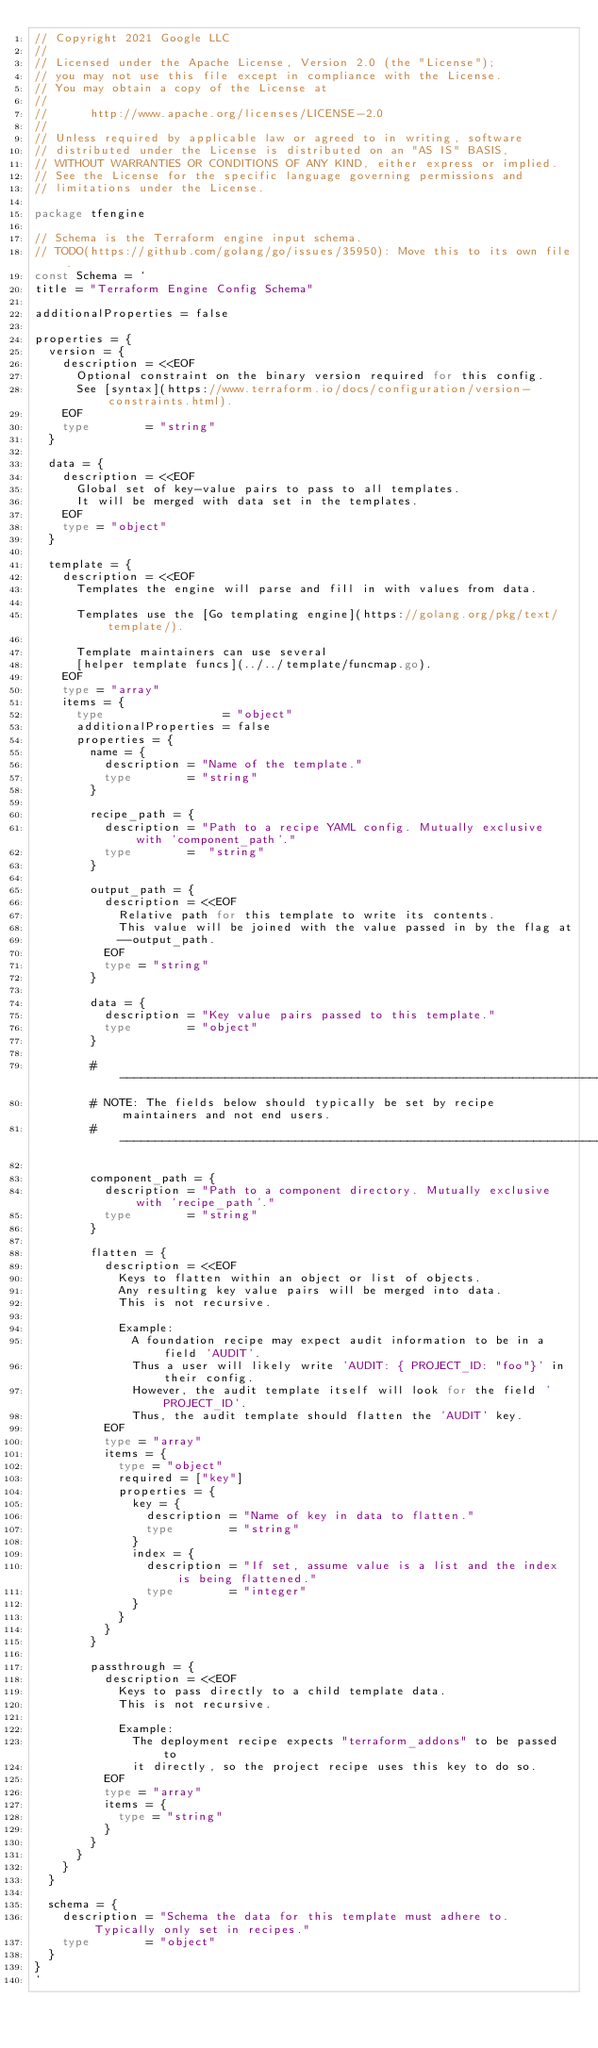Convert code to text. <code><loc_0><loc_0><loc_500><loc_500><_Go_>// Copyright 2021 Google LLC
//
// Licensed under the Apache License, Version 2.0 (the "License");
// you may not use this file except in compliance with the License.
// You may obtain a copy of the License at
//
//      http://www.apache.org/licenses/LICENSE-2.0
//
// Unless required by applicable law or agreed to in writing, software
// distributed under the License is distributed on an "AS IS" BASIS,
// WITHOUT WARRANTIES OR CONDITIONS OF ANY KIND, either express or implied.
// See the License for the specific language governing permissions and
// limitations under the License.

package tfengine

// Schema is the Terraform engine input schema.
// TODO(https://github.com/golang/go/issues/35950): Move this to its own file.
const Schema = `
title = "Terraform Engine Config Schema"

additionalProperties = false

properties = {
  version = {
    description = <<EOF
      Optional constraint on the binary version required for this config.
      See [syntax](https://www.terraform.io/docs/configuration/version-constraints.html).
    EOF
    type        = "string"
  }

  data = {
    description = <<EOF
      Global set of key-value pairs to pass to all templates.
      It will be merged with data set in the templates.
    EOF
    type = "object"
  }

  template = {
    description = <<EOF
      Templates the engine will parse and fill in with values from data.

      Templates use the [Go templating engine](https://golang.org/pkg/text/template/).

      Template maintainers can use several
      [helper template funcs](../../template/funcmap.go).
    EOF
    type = "array"
    items = {
      type                 = "object"
      additionalProperties = false
      properties = {
        name = {
          description = "Name of the template."
          type        = "string"
        }

        recipe_path = {
          description = "Path to a recipe YAML config. Mutually exclusive with 'component_path'."
          type        =  "string"
        }

        output_path = {
          description = <<EOF
            Relative path for this template to write its contents.
            This value will be joined with the value passed in by the flag at
            --output_path.
          EOF
          type = "string"
        }

        data = {
          description = "Key value pairs passed to this template."
          type        = "object"
        }

        # ----------------------------------------------------------------------
        # NOTE: The fields below should typically be set by recipe maintainers and not end users.
        # ----------------------------------------------------------------------

        component_path = {
          description = "Path to a component directory. Mutually exclusive with 'recipe_path'."
          type        = "string"
        }

        flatten = {
          description = <<EOF
            Keys to flatten within an object or list of objects.
            Any resulting key value pairs will be merged into data.
            This is not recursive.

            Example:
              A foundation recipe may expect audit information to be in a field 'AUDIT'.
              Thus a user will likely write 'AUDIT: { PROJECT_ID: "foo"}' in their config.
              However, the audit template itself will look for the field 'PROJECT_ID'.
              Thus, the audit template should flatten the 'AUDIT' key.
          EOF
          type = "array"
          items = {
            type = "object"
            required = ["key"]
            properties = {
              key = {
                description = "Name of key in data to flatten."
                type        = "string"
              }
              index = {
                description = "If set, assume value is a list and the index is being flattened."
                type        = "integer"
              }
            }
          }
        }

        passthrough = {
          description = <<EOF
            Keys to pass directly to a child template data.
            This is not recursive.

            Example:
              The deployment recipe expects "terraform_addons" to be passed to
              it directly, so the project recipe uses this key to do so.
          EOF
          type = "array"
          items = {
            type = "string"
          }
        }
      }
    }
  }

  schema = {
    description = "Schema the data for this template must adhere to. Typically only set in recipes."
    type        = "object"
  }
}
`
</code> 